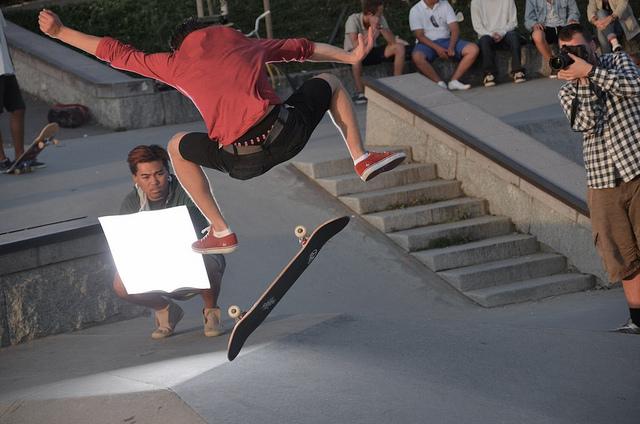What is he doing?
Be succinct. Skateboarding. Is someone taking a picture?
Write a very short answer. Yes. Is this called a flip-over?
Answer briefly. Yes. 